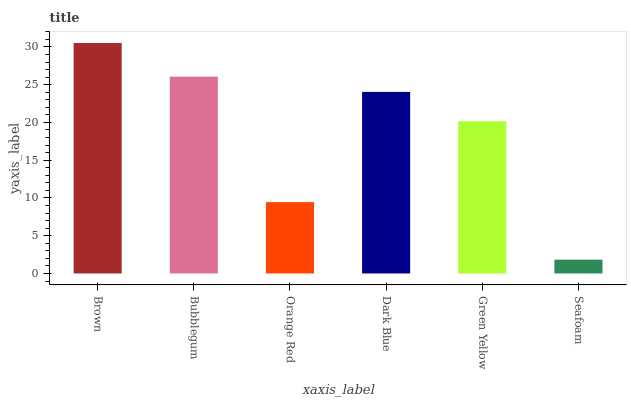Is Seafoam the minimum?
Answer yes or no. Yes. Is Brown the maximum?
Answer yes or no. Yes. Is Bubblegum the minimum?
Answer yes or no. No. Is Bubblegum the maximum?
Answer yes or no. No. Is Brown greater than Bubblegum?
Answer yes or no. Yes. Is Bubblegum less than Brown?
Answer yes or no. Yes. Is Bubblegum greater than Brown?
Answer yes or no. No. Is Brown less than Bubblegum?
Answer yes or no. No. Is Dark Blue the high median?
Answer yes or no. Yes. Is Green Yellow the low median?
Answer yes or no. Yes. Is Green Yellow the high median?
Answer yes or no. No. Is Dark Blue the low median?
Answer yes or no. No. 